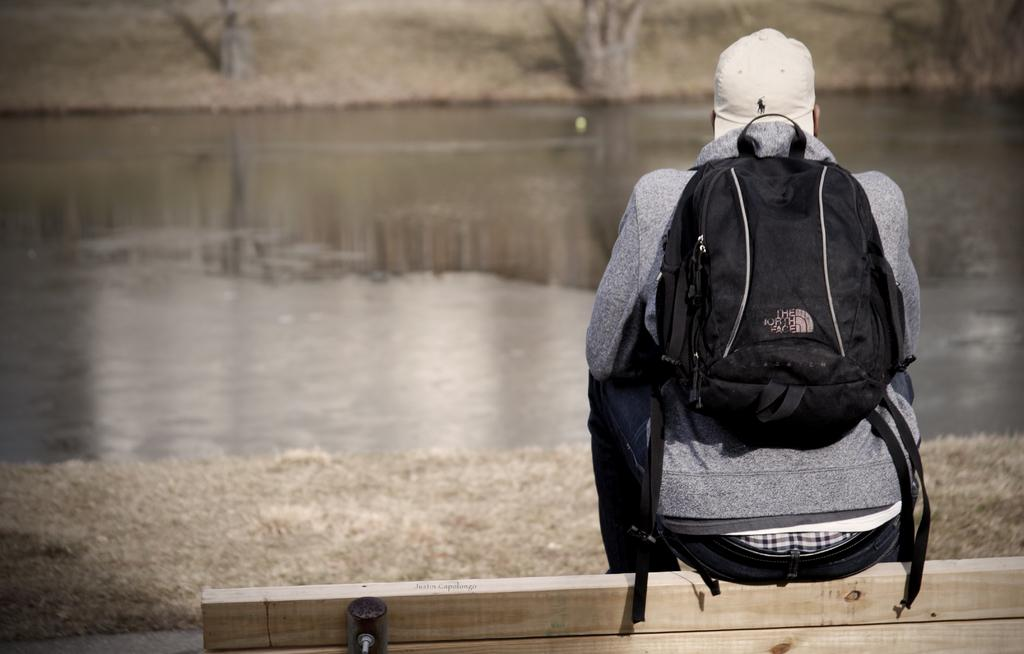Who is present in the image? There is a person in the image. What is the person wearing? The person is wearing a bag. What is the person doing in the image? The person is sitting on a bench. What can be seen in the background of the image? There is water and trees visible in the background. What type of quince is being used to decorate the home in the image? There is no quince present in the image, nor is there any indication of a home or decoration. 